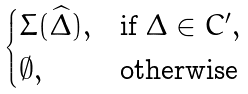Convert formula to latex. <formula><loc_0><loc_0><loc_500><loc_500>\begin{cases} \Sigma ( \widehat { \Delta } ) , & \text {if $\Delta \in C^{\prime}$} , \\ \emptyset , & \text {otherwise} \end{cases}</formula> 